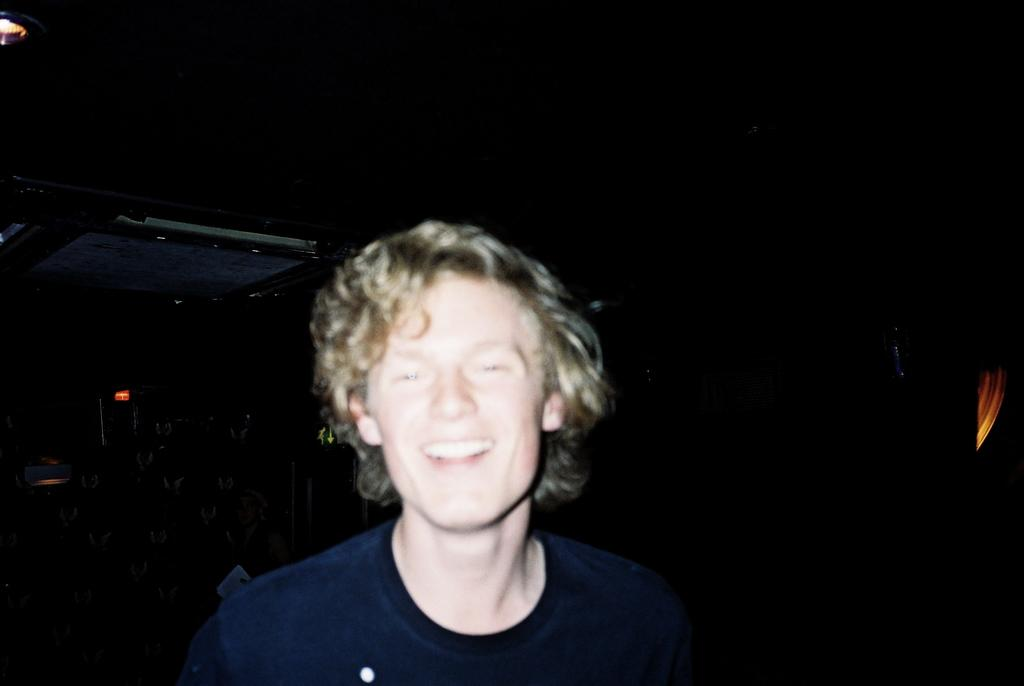What is happening in the image? There is a person in the image who is presenting. What can be seen behind the person? There is a black background in the image. What type of rock is being kissed by the person in the image? There is no rock or kissing activity present in the image. 